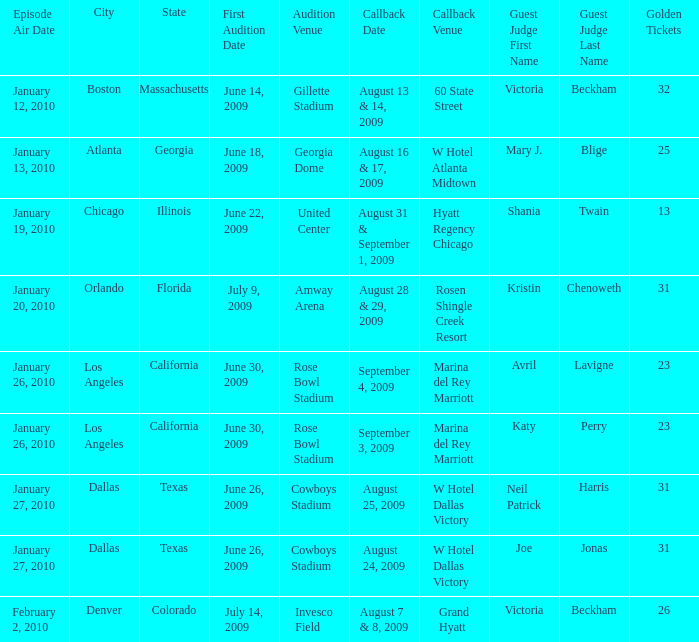Name the guest judge for first audition date being july 9, 2009 1.0. 